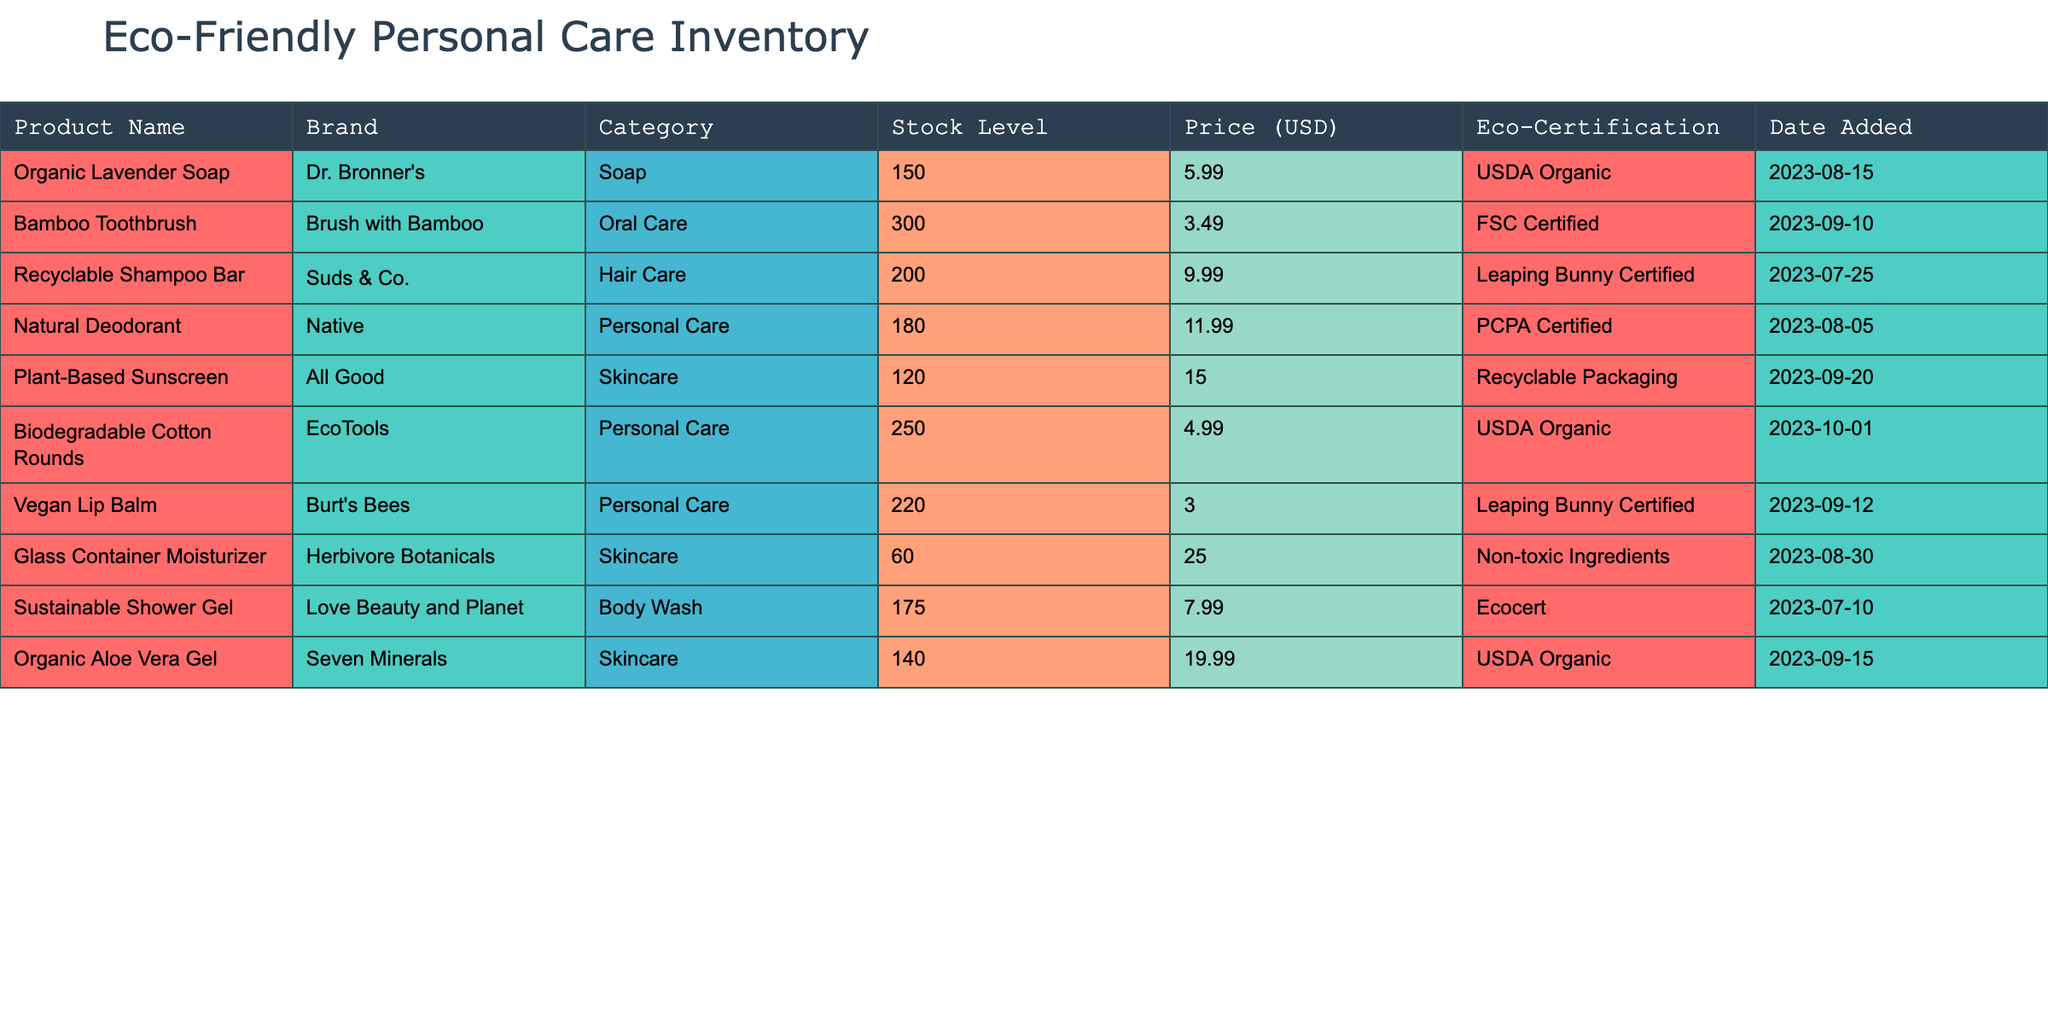What is the stock level of the Organic Lavender Soap? The table lists the product "Organic Lavender Soap" with a stock level of 150 units.
Answer: 150 Which product has the highest price? By comparing the prices listed, the "Glass Container Moisturizer" is priced at 25.00 USD, which is higher than all other products.
Answer: Glass Container Moisturizer Are all products eco-certified? The table shows that every product listed has some form of eco-certification, indicating they are all eco-friendly.
Answer: Yes What is the total stock level of Personal Care items in the inventory? The Personal Care category includes "Natural Deodorant" (180), "Biodegradable Cotton Rounds" (250), and "Vegan Lip Balm" (220), summing these gives: 180 + 250 + 220 = 650.
Answer: 650 How many products were added to the inventory in September 2023? The "Bamboo Toothbrush," "Plant-Based Sunscreen," and "Vegan Lip Balm" were all added in September, totaling three products.
Answer: 3 Which brand has the lowest stock level? The "Glass Container Moisturizer" from Herbivore Botanicals has a stock level of 60, which is the lowest among all products.
Answer: Herbivore Botanicals What is the average price of the Hair Care products? The Hair Care category consists of only the "Recyclable Shampoo Bar" priced at 9.99 USD, so the average price is 9.99 / 1 = 9.99.
Answer: 9.99 Is the Bamboo Toothbrush more expensive than the Biodegradable Cotton Rounds? The Bamboo Toothbrush costs 3.49 USD while the Biodegradable Cotton Rounds cost 4.99 USD, thus the toothbrush is less expensive.
Answer: No What is the difference in stock levels between the highest and lowest stocked products? The highest stock level is 300 (Bamboo Toothbrush) and the lowest is 60 (Glass Container Moisturizer). Calculating the difference gives 300 - 60 = 240.
Answer: 240 